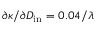<formula> <loc_0><loc_0><loc_500><loc_500>\partial \kappa / \partial D _ { i n } = 0 . 0 4 / \lambda</formula> 